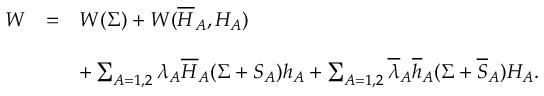<formula> <loc_0><loc_0><loc_500><loc_500>\begin{array} { c c l } { W } & { = } & { { W ( \Sigma ) + W ( \overline { H } _ { A } , H _ { A } ) } } & { { + \sum _ { A = 1 , 2 } \lambda _ { A } \overline { H } _ { A } ( \Sigma + S _ { A } ) h _ { A } + \sum _ { A = 1 , 2 } \overline { \lambda } _ { A } \overline { h } _ { A } ( \Sigma + \overline { S } _ { A } ) H _ { A } . } } \end{array}</formula> 